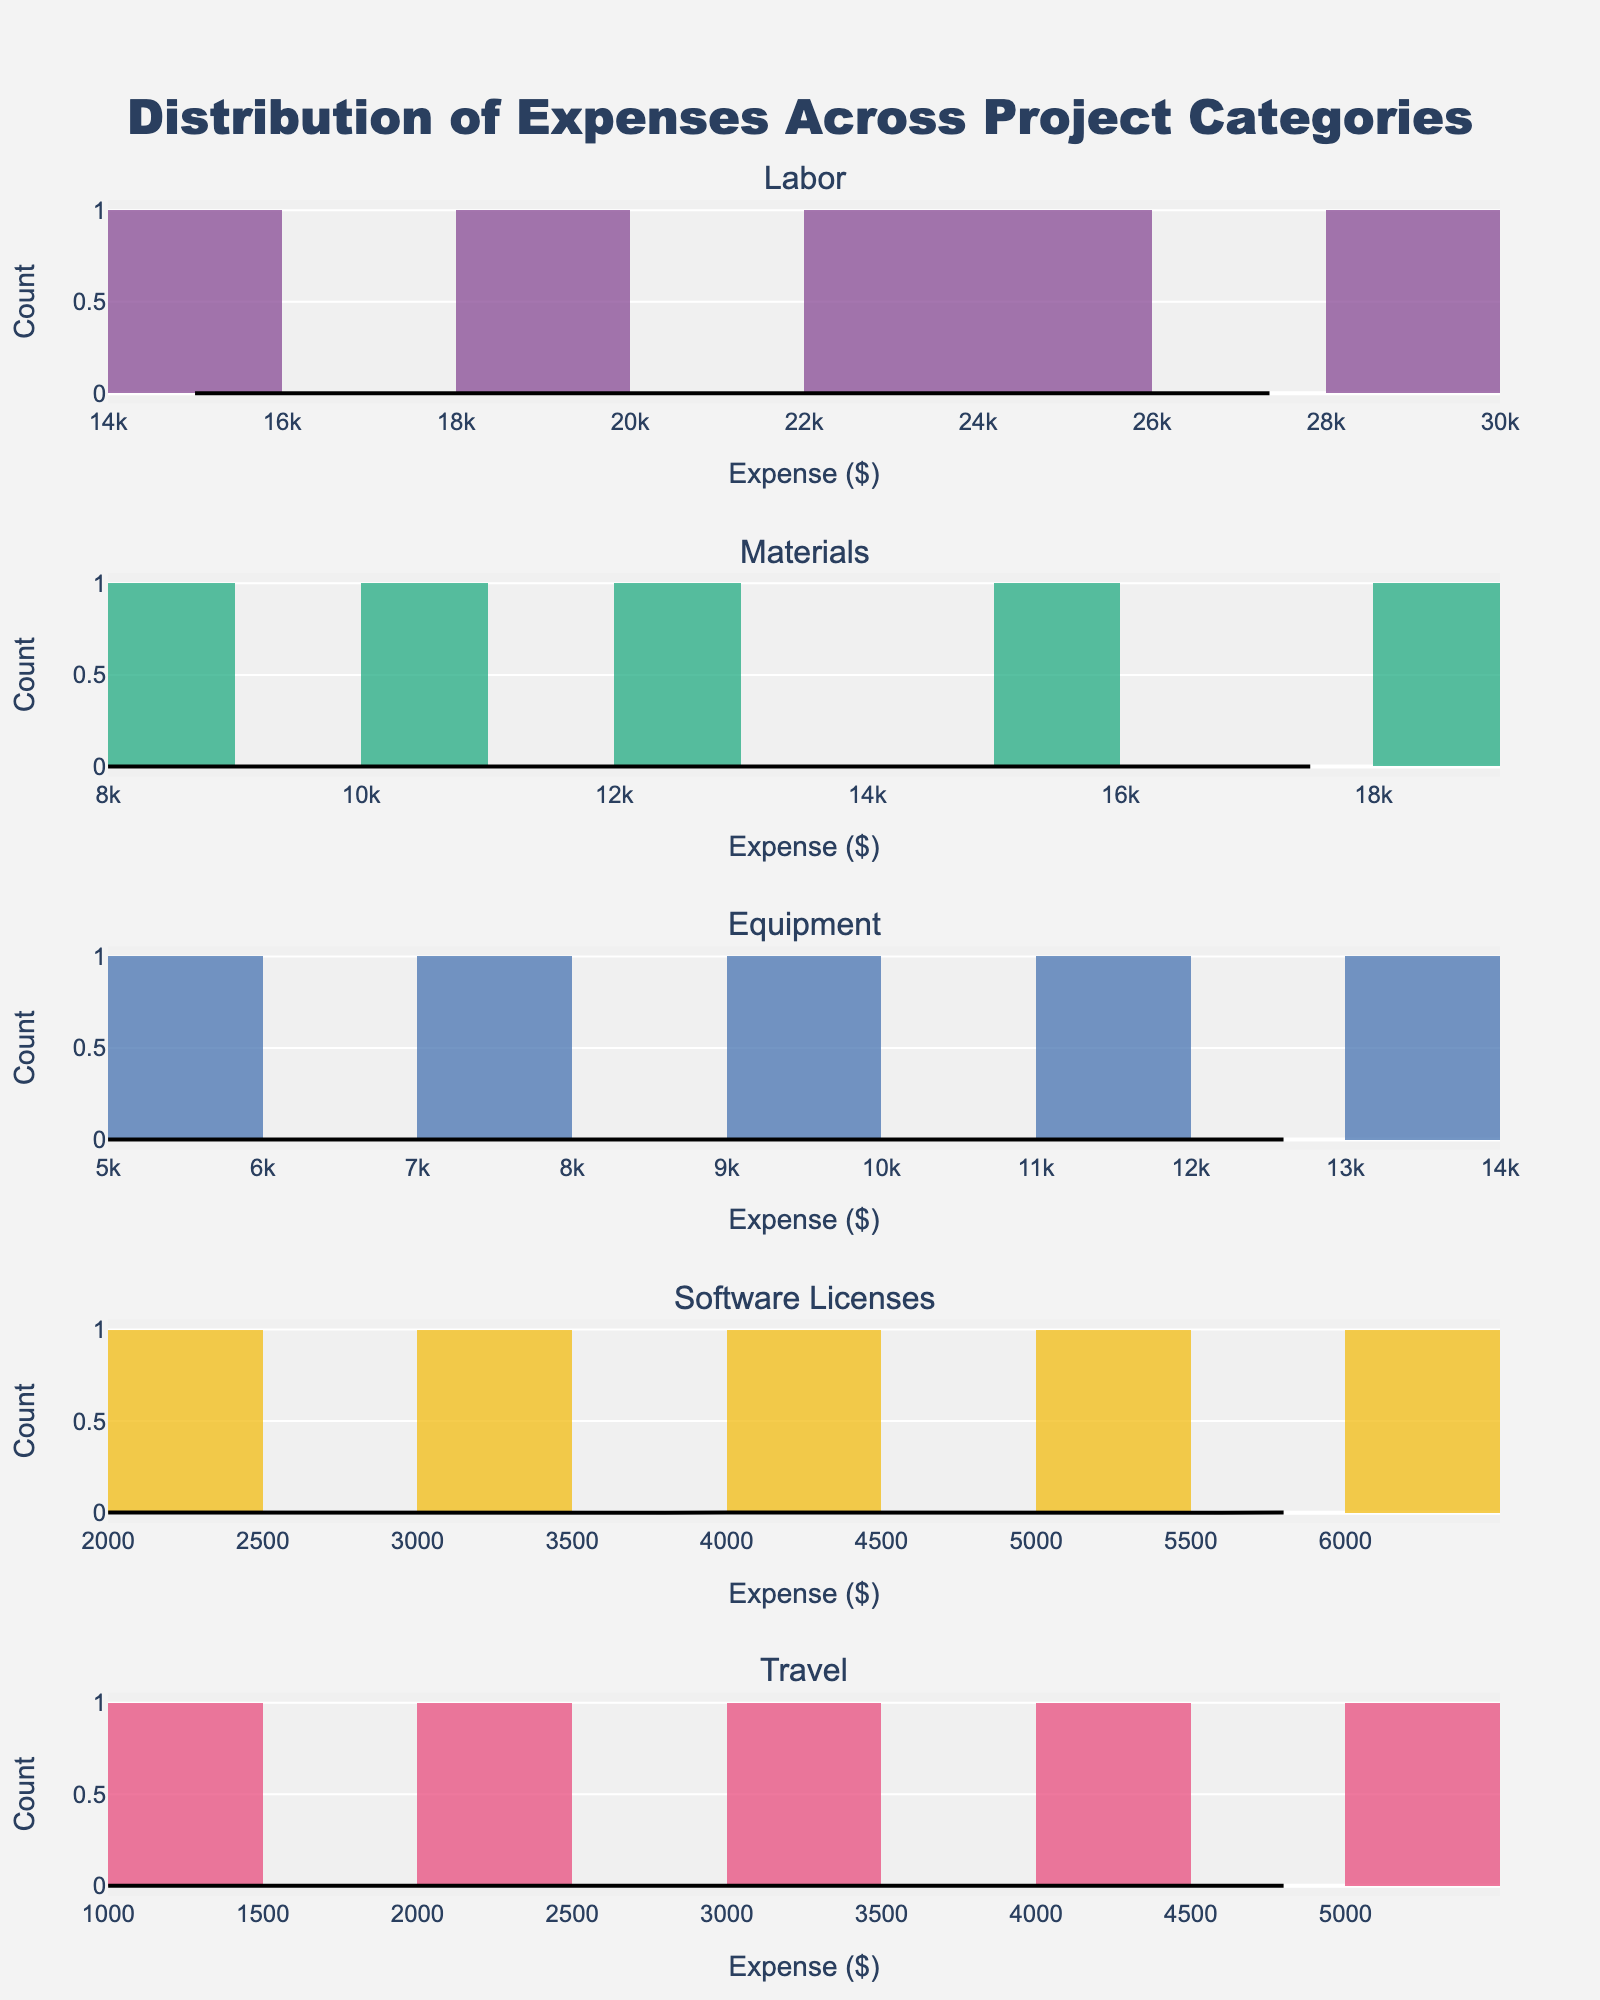What is the title of the figure? The title is usually found at the top of the figure. In this case, the title clearly states "Distribution of Expenses Across Project Categories".
Answer: Distribution of Expenses Across Project Categories How many project categories are shown in the figure? The number of subplot titles in the figure indicates the number of project categories. Each subplot represents a different category, and the code shows that there are five unique categories.
Answer: Five Which project category has the highest maximum expense? By scanning the histograms, we can identify the category with the highest maximum expense by looking at the histogram bars' highest extent on the x-axis. The "Labor" category stretches up to $28000.
Answer: Labor Does the "Materials" category show a wider range of expenses than the "Travel" category? To determine this, we need to compare the range (max expense - min expense) of both categories. For "Materials", the range is $18000 - $8000 = $10000. For "Travel", the range is $5000 - $1000 = $4000. Thus, "Materials" has a wider range.
Answer: Yes Which project category has the smallest maximum expense? By identifying the highest value in each histogram plot, the "Travel" category has the smallest maximum expense of $5000.
Answer: Travel What is the general distribution shape of expenses in the "Software Licenses" category? By observing the shape of the histogram and the KDE curve, we can infer the distribution shape. The "Software Licenses" category shows histograms mostly clustered towards the lower expense values with a long tail, indicating a right-skewed distribution.
Answer: Right-skewed Which project category has the closest expenses tightly clustered in a specific range? By examining the width of the histogram bars and the tightness of the KDE curve, the "Software Licenses" category has expenses tightly clustered between $2000 and $6000.
Answer: Software Licenses Between "Labor" and "Equipment" categories, which one has more evenly distributed expenses? The histogram and KDE curves for each category are compared to see the spread of expenses. The "Equipment" category shows a more uniform distribution, while "Labor" has a visible peak indicating less uniform distribution.
Answer: Equipment Are the expenses in the "Labor" category higher than those in the "Materials" category in general? By looking at both histograms' X-axes and comparing where the majority of expenses fall, the "Labor" category consistently displays higher expense values than the "Materials" category.
Answer: Yes 